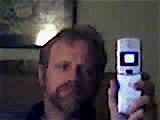How many men are there?
Give a very brief answer. 1. 